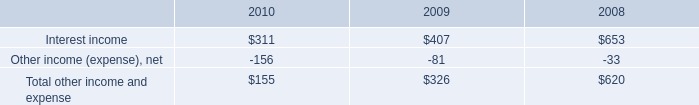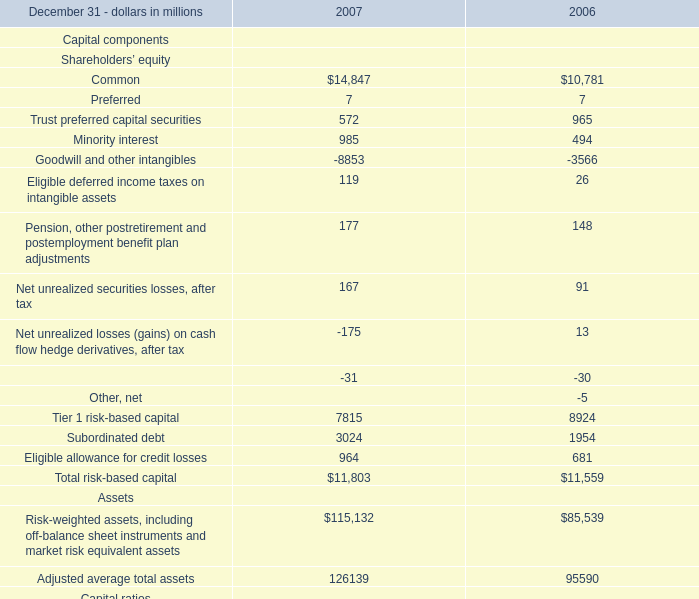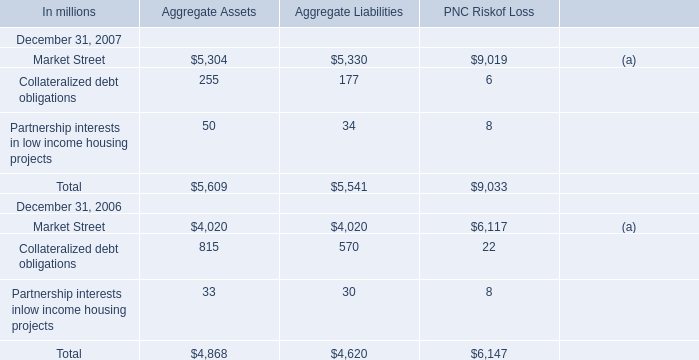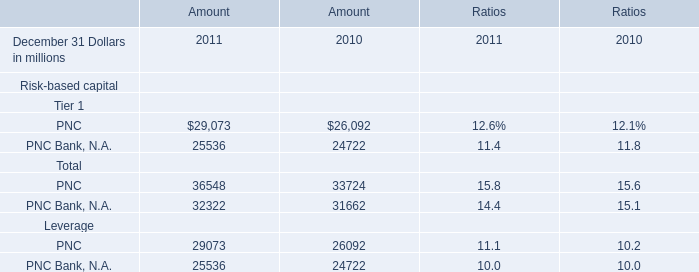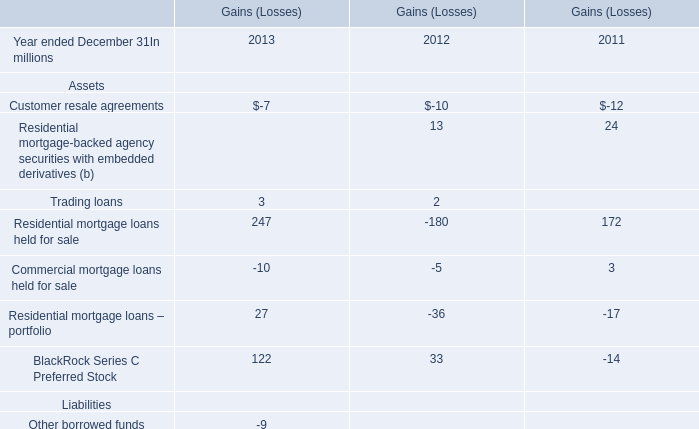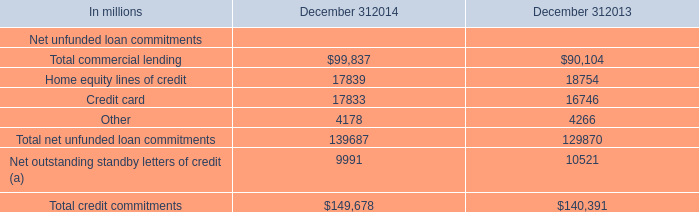What was the total amount of Aggregate Liabilities in 2007? (in million) 
Computations: ((5330 + 177) + 34)
Answer: 5541.0. 